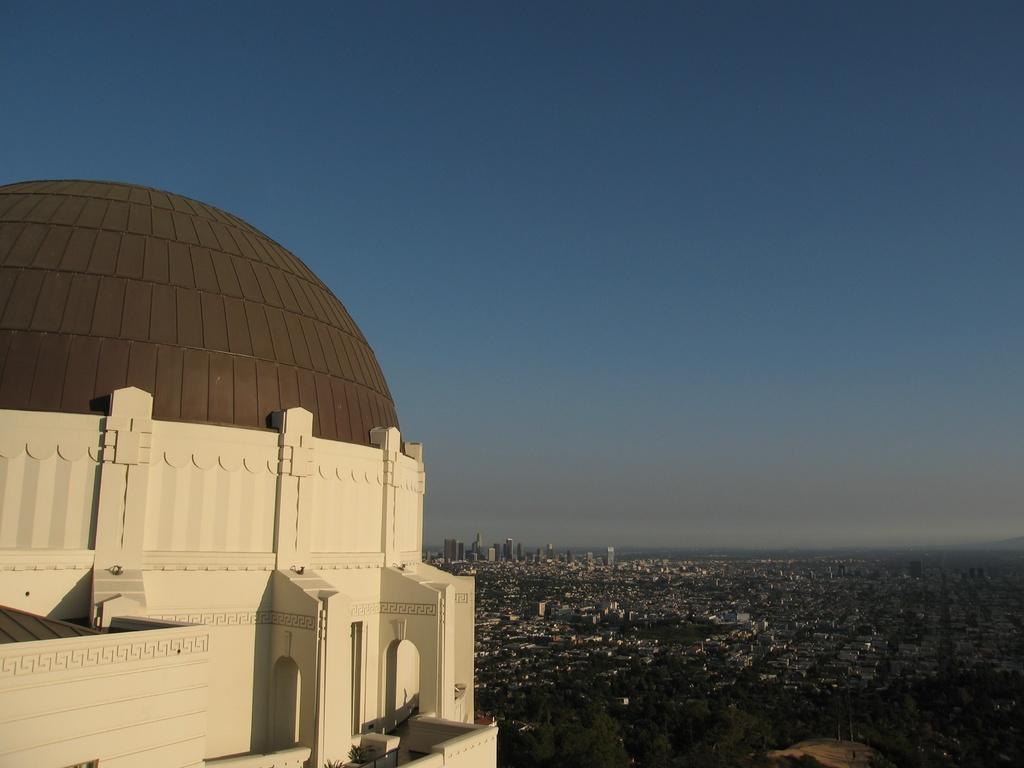How would you summarize this image in a sentence or two? On the left side there is the building, at the top it is the sky. 